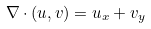Convert formula to latex. <formula><loc_0><loc_0><loc_500><loc_500>\nabla \cdot ( u , v ) = u _ { x } + v _ { y }</formula> 